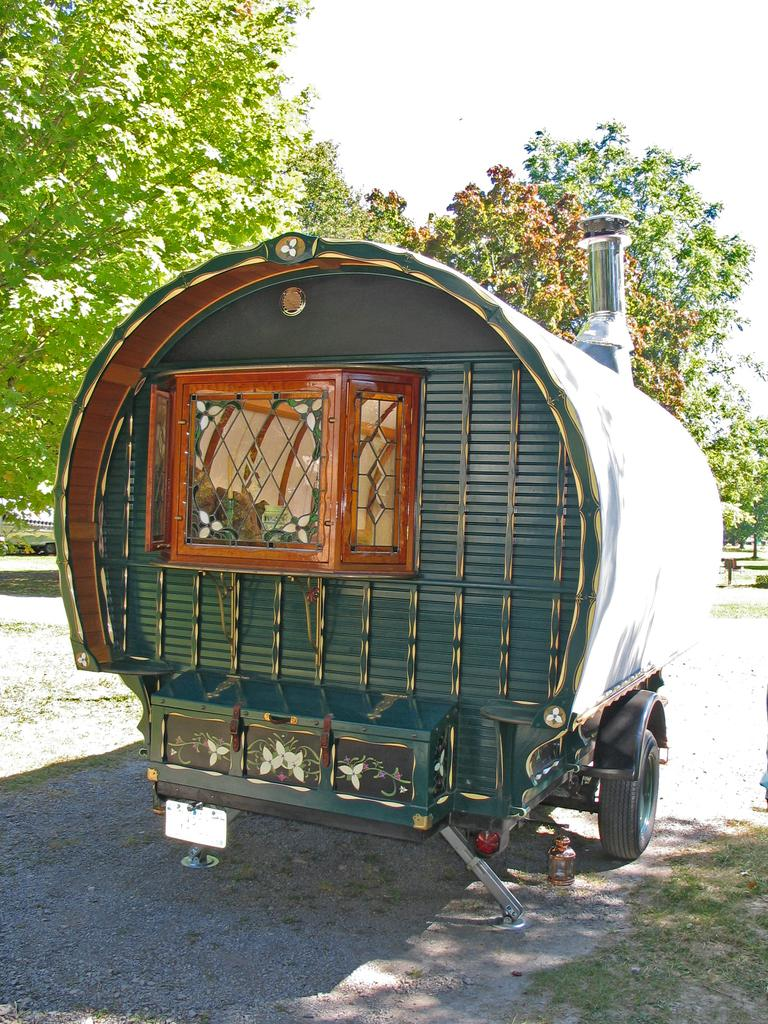What is the main subject of the image? There is a vehicle in the image. Where is the vehicle located? The vehicle is on a path. What can be seen in the background of the image? There are trees and the sky visible in the background of the image. Can you tell me what type of prose is being recited by the tiger in the image? There is no tiger present in the image, and therefore no prose being recited. 